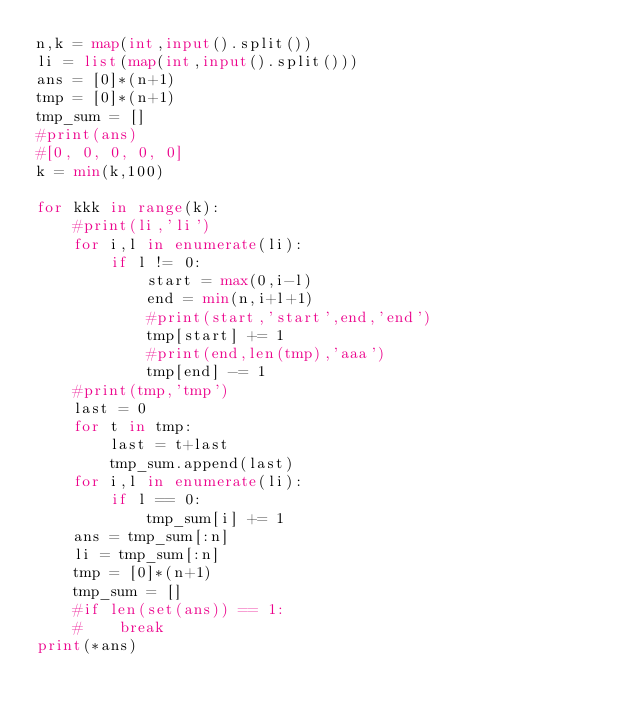<code> <loc_0><loc_0><loc_500><loc_500><_Python_>n,k = map(int,input().split())
li = list(map(int,input().split()))
ans = [0]*(n+1)
tmp = [0]*(n+1)
tmp_sum = []
#print(ans)
#[0, 0, 0, 0, 0]
k = min(k,100)

for kkk in range(k):
    #print(li,'li')
    for i,l in enumerate(li):
        if l != 0:
            start = max(0,i-l)
            end = min(n,i+l+1)
            #print(start,'start',end,'end')
            tmp[start] += 1
            #print(end,len(tmp),'aaa')
            tmp[end] -= 1
    #print(tmp,'tmp')
    last = 0
    for t in tmp:
        last = t+last
        tmp_sum.append(last)
    for i,l in enumerate(li):
        if l == 0:
            tmp_sum[i] += 1
    ans = tmp_sum[:n]
    li = tmp_sum[:n]
    tmp = [0]*(n+1)
    tmp_sum = []
    #if len(set(ans)) == 1:
    #    break
print(*ans)</code> 